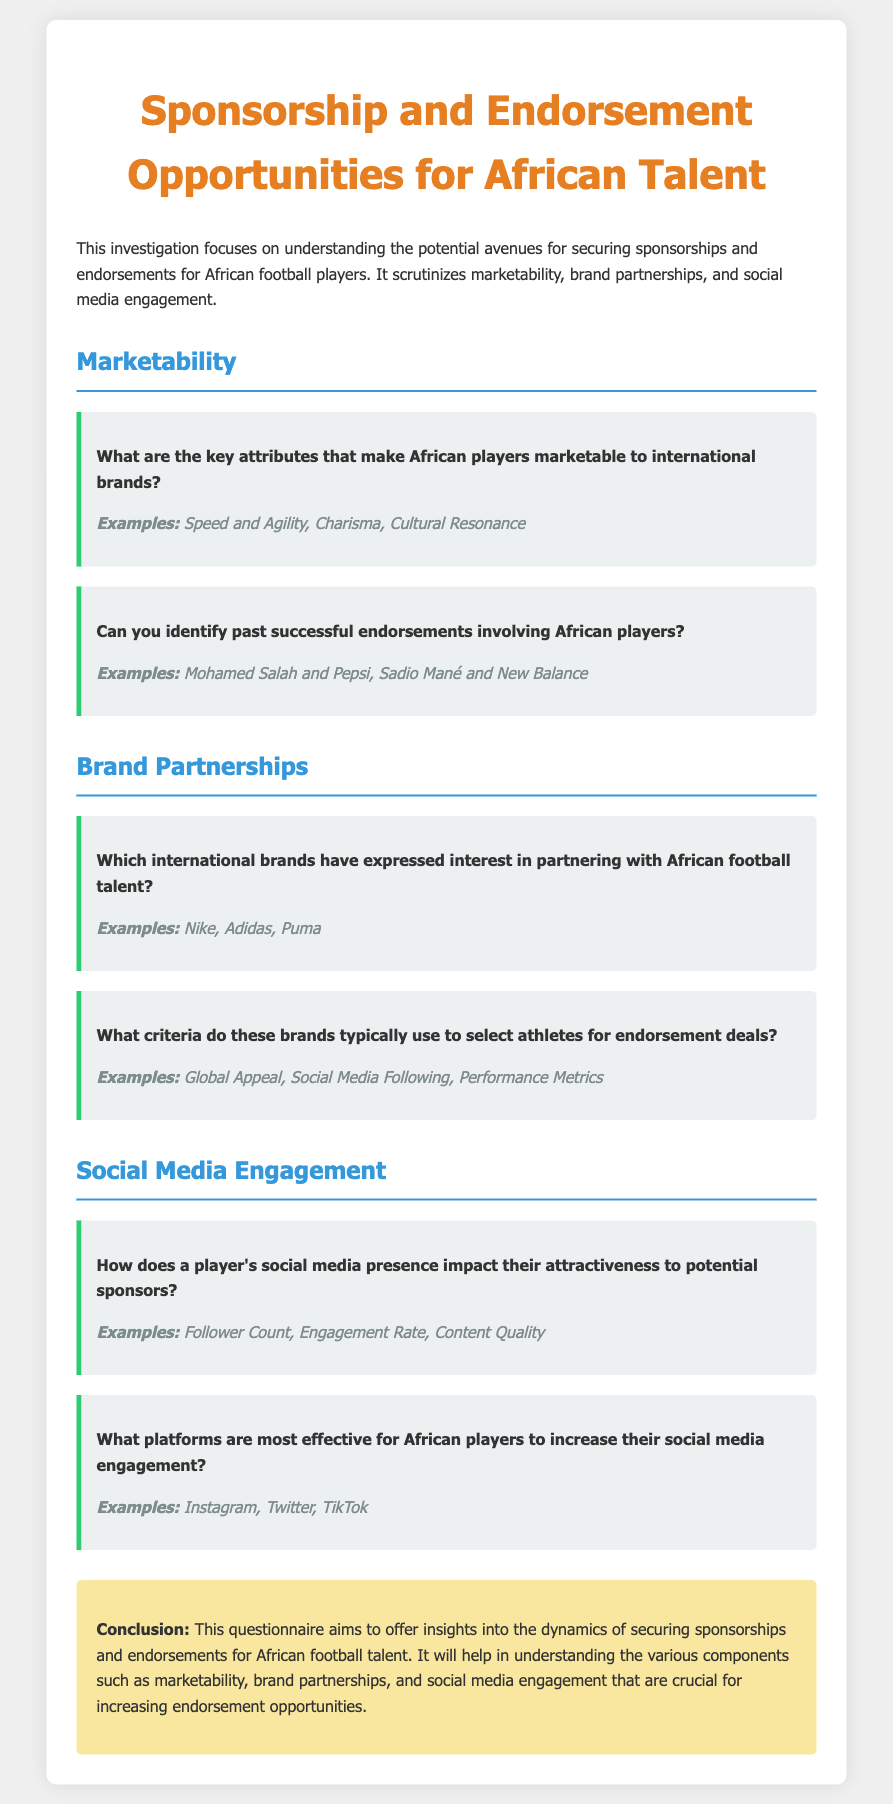What are the key attributes that make African players marketable? The document lists specific attributes that enhance marketability, including Speed and Agility, Charisma, and Cultural Resonance.
Answer: Speed and Agility, Charisma, Cultural Resonance Which international brands have expressed interest in partnering with African football talent? The document mentions specific brands that have shown interest, highlighting Nike, Adidas, and Puma.
Answer: Nike, Adidas, Puma What platforms are most effective for African players to increase their social media engagement? The document points out the primary platforms recommended for social media engagement; these include Instagram, Twitter, and TikTok.
Answer: Instagram, Twitter, TikTok Can you identify past successful endorsements involving African players? The document provides examples of successful endorsements, citing Mohamed Salah with Pepsi and Sadio Mané with New Balance.
Answer: Mohamed Salah and Pepsi, Sadio Mané and New Balance What criteria do brands typically use to select athletes for endorsement deals? The document enumerates criteria that brands consider, such as Global Appeal, Social Media Following, and Performance Metrics.
Answer: Global Appeal, Social Media Following, Performance Metrics How does a player's social media presence impact their attractiveness to potential sponsors? The document describes how aspects like Follower Count, Engagement Rate, and Content Quality play a significant role in sponsorship attractiveness.
Answer: Follower Count, Engagement Rate, Content Quality 